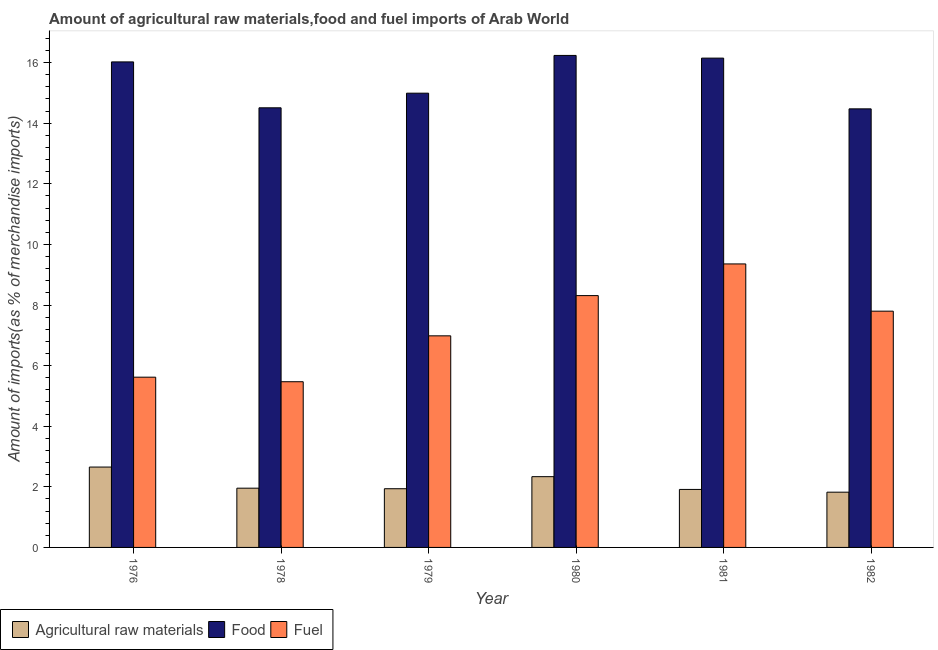Are the number of bars per tick equal to the number of legend labels?
Provide a short and direct response. Yes. Are the number of bars on each tick of the X-axis equal?
Make the answer very short. Yes. How many bars are there on the 6th tick from the left?
Offer a very short reply. 3. What is the percentage of fuel imports in 1976?
Give a very brief answer. 5.62. Across all years, what is the maximum percentage of food imports?
Make the answer very short. 16.24. Across all years, what is the minimum percentage of raw materials imports?
Provide a short and direct response. 1.82. In which year was the percentage of fuel imports maximum?
Offer a very short reply. 1981. In which year was the percentage of fuel imports minimum?
Your answer should be very brief. 1978. What is the total percentage of fuel imports in the graph?
Your answer should be compact. 43.53. What is the difference between the percentage of raw materials imports in 1981 and that in 1982?
Keep it short and to the point. 0.09. What is the difference between the percentage of raw materials imports in 1981 and the percentage of fuel imports in 1979?
Keep it short and to the point. -0.02. What is the average percentage of food imports per year?
Give a very brief answer. 15.4. What is the ratio of the percentage of fuel imports in 1981 to that in 1982?
Make the answer very short. 1.2. Is the percentage of fuel imports in 1980 less than that in 1982?
Provide a short and direct response. No. Is the difference between the percentage of raw materials imports in 1978 and 1981 greater than the difference between the percentage of food imports in 1978 and 1981?
Your answer should be compact. No. What is the difference between the highest and the second highest percentage of food imports?
Offer a terse response. 0.09. What is the difference between the highest and the lowest percentage of food imports?
Give a very brief answer. 1.76. In how many years, is the percentage of fuel imports greater than the average percentage of fuel imports taken over all years?
Provide a short and direct response. 3. Is the sum of the percentage of fuel imports in 1976 and 1980 greater than the maximum percentage of food imports across all years?
Offer a terse response. Yes. What does the 3rd bar from the left in 1979 represents?
Provide a short and direct response. Fuel. What does the 1st bar from the right in 1980 represents?
Your response must be concise. Fuel. Is it the case that in every year, the sum of the percentage of raw materials imports and percentage of food imports is greater than the percentage of fuel imports?
Offer a terse response. Yes. How many bars are there?
Offer a very short reply. 18. Are the values on the major ticks of Y-axis written in scientific E-notation?
Your response must be concise. No. Where does the legend appear in the graph?
Keep it short and to the point. Bottom left. How many legend labels are there?
Offer a terse response. 3. How are the legend labels stacked?
Your answer should be very brief. Horizontal. What is the title of the graph?
Offer a terse response. Amount of agricultural raw materials,food and fuel imports of Arab World. What is the label or title of the X-axis?
Offer a very short reply. Year. What is the label or title of the Y-axis?
Give a very brief answer. Amount of imports(as % of merchandise imports). What is the Amount of imports(as % of merchandise imports) in Agricultural raw materials in 1976?
Your response must be concise. 2.65. What is the Amount of imports(as % of merchandise imports) of Food in 1976?
Give a very brief answer. 16.02. What is the Amount of imports(as % of merchandise imports) in Fuel in 1976?
Your response must be concise. 5.62. What is the Amount of imports(as % of merchandise imports) in Agricultural raw materials in 1978?
Offer a terse response. 1.96. What is the Amount of imports(as % of merchandise imports) in Food in 1978?
Give a very brief answer. 14.51. What is the Amount of imports(as % of merchandise imports) in Fuel in 1978?
Ensure brevity in your answer.  5.47. What is the Amount of imports(as % of merchandise imports) of Agricultural raw materials in 1979?
Provide a succinct answer. 1.94. What is the Amount of imports(as % of merchandise imports) of Food in 1979?
Offer a terse response. 14.99. What is the Amount of imports(as % of merchandise imports) of Fuel in 1979?
Make the answer very short. 6.98. What is the Amount of imports(as % of merchandise imports) of Agricultural raw materials in 1980?
Keep it short and to the point. 2.34. What is the Amount of imports(as % of merchandise imports) of Food in 1980?
Your response must be concise. 16.24. What is the Amount of imports(as % of merchandise imports) of Fuel in 1980?
Offer a terse response. 8.31. What is the Amount of imports(as % of merchandise imports) of Agricultural raw materials in 1981?
Offer a terse response. 1.91. What is the Amount of imports(as % of merchandise imports) of Food in 1981?
Offer a very short reply. 16.15. What is the Amount of imports(as % of merchandise imports) in Fuel in 1981?
Your answer should be very brief. 9.36. What is the Amount of imports(as % of merchandise imports) of Agricultural raw materials in 1982?
Your answer should be very brief. 1.82. What is the Amount of imports(as % of merchandise imports) of Food in 1982?
Provide a short and direct response. 14.47. What is the Amount of imports(as % of merchandise imports) of Fuel in 1982?
Provide a succinct answer. 7.8. Across all years, what is the maximum Amount of imports(as % of merchandise imports) in Agricultural raw materials?
Provide a short and direct response. 2.65. Across all years, what is the maximum Amount of imports(as % of merchandise imports) in Food?
Provide a short and direct response. 16.24. Across all years, what is the maximum Amount of imports(as % of merchandise imports) of Fuel?
Your answer should be very brief. 9.36. Across all years, what is the minimum Amount of imports(as % of merchandise imports) in Agricultural raw materials?
Your response must be concise. 1.82. Across all years, what is the minimum Amount of imports(as % of merchandise imports) of Food?
Make the answer very short. 14.47. Across all years, what is the minimum Amount of imports(as % of merchandise imports) in Fuel?
Your answer should be very brief. 5.47. What is the total Amount of imports(as % of merchandise imports) of Agricultural raw materials in the graph?
Make the answer very short. 12.62. What is the total Amount of imports(as % of merchandise imports) of Food in the graph?
Your response must be concise. 92.38. What is the total Amount of imports(as % of merchandise imports) of Fuel in the graph?
Your response must be concise. 43.53. What is the difference between the Amount of imports(as % of merchandise imports) of Agricultural raw materials in 1976 and that in 1978?
Provide a short and direct response. 0.7. What is the difference between the Amount of imports(as % of merchandise imports) in Food in 1976 and that in 1978?
Your response must be concise. 1.51. What is the difference between the Amount of imports(as % of merchandise imports) of Agricultural raw materials in 1976 and that in 1979?
Offer a very short reply. 0.71. What is the difference between the Amount of imports(as % of merchandise imports) of Food in 1976 and that in 1979?
Give a very brief answer. 1.03. What is the difference between the Amount of imports(as % of merchandise imports) in Fuel in 1976 and that in 1979?
Give a very brief answer. -1.36. What is the difference between the Amount of imports(as % of merchandise imports) of Agricultural raw materials in 1976 and that in 1980?
Your response must be concise. 0.32. What is the difference between the Amount of imports(as % of merchandise imports) of Food in 1976 and that in 1980?
Make the answer very short. -0.21. What is the difference between the Amount of imports(as % of merchandise imports) of Fuel in 1976 and that in 1980?
Your response must be concise. -2.69. What is the difference between the Amount of imports(as % of merchandise imports) of Agricultural raw materials in 1976 and that in 1981?
Ensure brevity in your answer.  0.74. What is the difference between the Amount of imports(as % of merchandise imports) in Food in 1976 and that in 1981?
Make the answer very short. -0.12. What is the difference between the Amount of imports(as % of merchandise imports) in Fuel in 1976 and that in 1981?
Your answer should be compact. -3.74. What is the difference between the Amount of imports(as % of merchandise imports) in Agricultural raw materials in 1976 and that in 1982?
Make the answer very short. 0.83. What is the difference between the Amount of imports(as % of merchandise imports) in Food in 1976 and that in 1982?
Provide a succinct answer. 1.55. What is the difference between the Amount of imports(as % of merchandise imports) of Fuel in 1976 and that in 1982?
Provide a short and direct response. -2.18. What is the difference between the Amount of imports(as % of merchandise imports) of Agricultural raw materials in 1978 and that in 1979?
Give a very brief answer. 0.02. What is the difference between the Amount of imports(as % of merchandise imports) in Food in 1978 and that in 1979?
Your response must be concise. -0.48. What is the difference between the Amount of imports(as % of merchandise imports) of Fuel in 1978 and that in 1979?
Ensure brevity in your answer.  -1.51. What is the difference between the Amount of imports(as % of merchandise imports) in Agricultural raw materials in 1978 and that in 1980?
Give a very brief answer. -0.38. What is the difference between the Amount of imports(as % of merchandise imports) of Food in 1978 and that in 1980?
Offer a terse response. -1.73. What is the difference between the Amount of imports(as % of merchandise imports) in Fuel in 1978 and that in 1980?
Ensure brevity in your answer.  -2.84. What is the difference between the Amount of imports(as % of merchandise imports) of Agricultural raw materials in 1978 and that in 1981?
Keep it short and to the point. 0.04. What is the difference between the Amount of imports(as % of merchandise imports) in Food in 1978 and that in 1981?
Give a very brief answer. -1.64. What is the difference between the Amount of imports(as % of merchandise imports) in Fuel in 1978 and that in 1981?
Make the answer very short. -3.89. What is the difference between the Amount of imports(as % of merchandise imports) in Agricultural raw materials in 1978 and that in 1982?
Offer a very short reply. 0.13. What is the difference between the Amount of imports(as % of merchandise imports) of Food in 1978 and that in 1982?
Provide a succinct answer. 0.03. What is the difference between the Amount of imports(as % of merchandise imports) in Fuel in 1978 and that in 1982?
Your answer should be compact. -2.33. What is the difference between the Amount of imports(as % of merchandise imports) of Agricultural raw materials in 1979 and that in 1980?
Provide a short and direct response. -0.4. What is the difference between the Amount of imports(as % of merchandise imports) of Food in 1979 and that in 1980?
Make the answer very short. -1.25. What is the difference between the Amount of imports(as % of merchandise imports) in Fuel in 1979 and that in 1980?
Give a very brief answer. -1.33. What is the difference between the Amount of imports(as % of merchandise imports) in Agricultural raw materials in 1979 and that in 1981?
Make the answer very short. 0.02. What is the difference between the Amount of imports(as % of merchandise imports) of Food in 1979 and that in 1981?
Give a very brief answer. -1.16. What is the difference between the Amount of imports(as % of merchandise imports) in Fuel in 1979 and that in 1981?
Provide a short and direct response. -2.37. What is the difference between the Amount of imports(as % of merchandise imports) in Agricultural raw materials in 1979 and that in 1982?
Offer a terse response. 0.11. What is the difference between the Amount of imports(as % of merchandise imports) in Food in 1979 and that in 1982?
Provide a succinct answer. 0.52. What is the difference between the Amount of imports(as % of merchandise imports) in Fuel in 1979 and that in 1982?
Give a very brief answer. -0.81. What is the difference between the Amount of imports(as % of merchandise imports) of Agricultural raw materials in 1980 and that in 1981?
Keep it short and to the point. 0.42. What is the difference between the Amount of imports(as % of merchandise imports) in Food in 1980 and that in 1981?
Make the answer very short. 0.09. What is the difference between the Amount of imports(as % of merchandise imports) of Fuel in 1980 and that in 1981?
Keep it short and to the point. -1.05. What is the difference between the Amount of imports(as % of merchandise imports) in Agricultural raw materials in 1980 and that in 1982?
Your answer should be very brief. 0.51. What is the difference between the Amount of imports(as % of merchandise imports) in Food in 1980 and that in 1982?
Your answer should be very brief. 1.76. What is the difference between the Amount of imports(as % of merchandise imports) of Fuel in 1980 and that in 1982?
Ensure brevity in your answer.  0.51. What is the difference between the Amount of imports(as % of merchandise imports) in Agricultural raw materials in 1981 and that in 1982?
Offer a very short reply. 0.09. What is the difference between the Amount of imports(as % of merchandise imports) in Food in 1981 and that in 1982?
Your answer should be very brief. 1.67. What is the difference between the Amount of imports(as % of merchandise imports) in Fuel in 1981 and that in 1982?
Give a very brief answer. 1.56. What is the difference between the Amount of imports(as % of merchandise imports) of Agricultural raw materials in 1976 and the Amount of imports(as % of merchandise imports) of Food in 1978?
Your answer should be compact. -11.86. What is the difference between the Amount of imports(as % of merchandise imports) of Agricultural raw materials in 1976 and the Amount of imports(as % of merchandise imports) of Fuel in 1978?
Give a very brief answer. -2.82. What is the difference between the Amount of imports(as % of merchandise imports) in Food in 1976 and the Amount of imports(as % of merchandise imports) in Fuel in 1978?
Give a very brief answer. 10.55. What is the difference between the Amount of imports(as % of merchandise imports) in Agricultural raw materials in 1976 and the Amount of imports(as % of merchandise imports) in Food in 1979?
Your answer should be very brief. -12.34. What is the difference between the Amount of imports(as % of merchandise imports) of Agricultural raw materials in 1976 and the Amount of imports(as % of merchandise imports) of Fuel in 1979?
Your response must be concise. -4.33. What is the difference between the Amount of imports(as % of merchandise imports) of Food in 1976 and the Amount of imports(as % of merchandise imports) of Fuel in 1979?
Keep it short and to the point. 9.04. What is the difference between the Amount of imports(as % of merchandise imports) of Agricultural raw materials in 1976 and the Amount of imports(as % of merchandise imports) of Food in 1980?
Ensure brevity in your answer.  -13.58. What is the difference between the Amount of imports(as % of merchandise imports) of Agricultural raw materials in 1976 and the Amount of imports(as % of merchandise imports) of Fuel in 1980?
Make the answer very short. -5.66. What is the difference between the Amount of imports(as % of merchandise imports) of Food in 1976 and the Amount of imports(as % of merchandise imports) of Fuel in 1980?
Ensure brevity in your answer.  7.71. What is the difference between the Amount of imports(as % of merchandise imports) in Agricultural raw materials in 1976 and the Amount of imports(as % of merchandise imports) in Food in 1981?
Ensure brevity in your answer.  -13.5. What is the difference between the Amount of imports(as % of merchandise imports) in Agricultural raw materials in 1976 and the Amount of imports(as % of merchandise imports) in Fuel in 1981?
Your response must be concise. -6.7. What is the difference between the Amount of imports(as % of merchandise imports) of Food in 1976 and the Amount of imports(as % of merchandise imports) of Fuel in 1981?
Offer a very short reply. 6.67. What is the difference between the Amount of imports(as % of merchandise imports) of Agricultural raw materials in 1976 and the Amount of imports(as % of merchandise imports) of Food in 1982?
Offer a terse response. -11.82. What is the difference between the Amount of imports(as % of merchandise imports) of Agricultural raw materials in 1976 and the Amount of imports(as % of merchandise imports) of Fuel in 1982?
Your answer should be very brief. -5.14. What is the difference between the Amount of imports(as % of merchandise imports) of Food in 1976 and the Amount of imports(as % of merchandise imports) of Fuel in 1982?
Offer a terse response. 8.23. What is the difference between the Amount of imports(as % of merchandise imports) in Agricultural raw materials in 1978 and the Amount of imports(as % of merchandise imports) in Food in 1979?
Give a very brief answer. -13.04. What is the difference between the Amount of imports(as % of merchandise imports) of Agricultural raw materials in 1978 and the Amount of imports(as % of merchandise imports) of Fuel in 1979?
Provide a succinct answer. -5.03. What is the difference between the Amount of imports(as % of merchandise imports) of Food in 1978 and the Amount of imports(as % of merchandise imports) of Fuel in 1979?
Offer a terse response. 7.53. What is the difference between the Amount of imports(as % of merchandise imports) of Agricultural raw materials in 1978 and the Amount of imports(as % of merchandise imports) of Food in 1980?
Give a very brief answer. -14.28. What is the difference between the Amount of imports(as % of merchandise imports) of Agricultural raw materials in 1978 and the Amount of imports(as % of merchandise imports) of Fuel in 1980?
Offer a very short reply. -6.36. What is the difference between the Amount of imports(as % of merchandise imports) in Food in 1978 and the Amount of imports(as % of merchandise imports) in Fuel in 1980?
Your answer should be compact. 6.2. What is the difference between the Amount of imports(as % of merchandise imports) of Agricultural raw materials in 1978 and the Amount of imports(as % of merchandise imports) of Food in 1981?
Keep it short and to the point. -14.19. What is the difference between the Amount of imports(as % of merchandise imports) in Agricultural raw materials in 1978 and the Amount of imports(as % of merchandise imports) in Fuel in 1981?
Ensure brevity in your answer.  -7.4. What is the difference between the Amount of imports(as % of merchandise imports) of Food in 1978 and the Amount of imports(as % of merchandise imports) of Fuel in 1981?
Provide a short and direct response. 5.15. What is the difference between the Amount of imports(as % of merchandise imports) in Agricultural raw materials in 1978 and the Amount of imports(as % of merchandise imports) in Food in 1982?
Make the answer very short. -12.52. What is the difference between the Amount of imports(as % of merchandise imports) in Agricultural raw materials in 1978 and the Amount of imports(as % of merchandise imports) in Fuel in 1982?
Offer a terse response. -5.84. What is the difference between the Amount of imports(as % of merchandise imports) in Food in 1978 and the Amount of imports(as % of merchandise imports) in Fuel in 1982?
Offer a terse response. 6.71. What is the difference between the Amount of imports(as % of merchandise imports) in Agricultural raw materials in 1979 and the Amount of imports(as % of merchandise imports) in Food in 1980?
Your answer should be compact. -14.3. What is the difference between the Amount of imports(as % of merchandise imports) in Agricultural raw materials in 1979 and the Amount of imports(as % of merchandise imports) in Fuel in 1980?
Provide a succinct answer. -6.37. What is the difference between the Amount of imports(as % of merchandise imports) of Food in 1979 and the Amount of imports(as % of merchandise imports) of Fuel in 1980?
Offer a very short reply. 6.68. What is the difference between the Amount of imports(as % of merchandise imports) of Agricultural raw materials in 1979 and the Amount of imports(as % of merchandise imports) of Food in 1981?
Offer a very short reply. -14.21. What is the difference between the Amount of imports(as % of merchandise imports) of Agricultural raw materials in 1979 and the Amount of imports(as % of merchandise imports) of Fuel in 1981?
Your answer should be compact. -7.42. What is the difference between the Amount of imports(as % of merchandise imports) in Food in 1979 and the Amount of imports(as % of merchandise imports) in Fuel in 1981?
Your answer should be very brief. 5.63. What is the difference between the Amount of imports(as % of merchandise imports) of Agricultural raw materials in 1979 and the Amount of imports(as % of merchandise imports) of Food in 1982?
Your answer should be compact. -12.54. What is the difference between the Amount of imports(as % of merchandise imports) in Agricultural raw materials in 1979 and the Amount of imports(as % of merchandise imports) in Fuel in 1982?
Your answer should be compact. -5.86. What is the difference between the Amount of imports(as % of merchandise imports) in Food in 1979 and the Amount of imports(as % of merchandise imports) in Fuel in 1982?
Provide a short and direct response. 7.19. What is the difference between the Amount of imports(as % of merchandise imports) in Agricultural raw materials in 1980 and the Amount of imports(as % of merchandise imports) in Food in 1981?
Keep it short and to the point. -13.81. What is the difference between the Amount of imports(as % of merchandise imports) in Agricultural raw materials in 1980 and the Amount of imports(as % of merchandise imports) in Fuel in 1981?
Give a very brief answer. -7.02. What is the difference between the Amount of imports(as % of merchandise imports) of Food in 1980 and the Amount of imports(as % of merchandise imports) of Fuel in 1981?
Ensure brevity in your answer.  6.88. What is the difference between the Amount of imports(as % of merchandise imports) in Agricultural raw materials in 1980 and the Amount of imports(as % of merchandise imports) in Food in 1982?
Offer a terse response. -12.14. What is the difference between the Amount of imports(as % of merchandise imports) in Agricultural raw materials in 1980 and the Amount of imports(as % of merchandise imports) in Fuel in 1982?
Provide a short and direct response. -5.46. What is the difference between the Amount of imports(as % of merchandise imports) in Food in 1980 and the Amount of imports(as % of merchandise imports) in Fuel in 1982?
Make the answer very short. 8.44. What is the difference between the Amount of imports(as % of merchandise imports) of Agricultural raw materials in 1981 and the Amount of imports(as % of merchandise imports) of Food in 1982?
Provide a succinct answer. -12.56. What is the difference between the Amount of imports(as % of merchandise imports) of Agricultural raw materials in 1981 and the Amount of imports(as % of merchandise imports) of Fuel in 1982?
Provide a succinct answer. -5.88. What is the difference between the Amount of imports(as % of merchandise imports) in Food in 1981 and the Amount of imports(as % of merchandise imports) in Fuel in 1982?
Your answer should be very brief. 8.35. What is the average Amount of imports(as % of merchandise imports) in Agricultural raw materials per year?
Provide a short and direct response. 2.1. What is the average Amount of imports(as % of merchandise imports) in Food per year?
Keep it short and to the point. 15.4. What is the average Amount of imports(as % of merchandise imports) in Fuel per year?
Your answer should be compact. 7.26. In the year 1976, what is the difference between the Amount of imports(as % of merchandise imports) of Agricultural raw materials and Amount of imports(as % of merchandise imports) of Food?
Your answer should be very brief. -13.37. In the year 1976, what is the difference between the Amount of imports(as % of merchandise imports) of Agricultural raw materials and Amount of imports(as % of merchandise imports) of Fuel?
Provide a succinct answer. -2.97. In the year 1976, what is the difference between the Amount of imports(as % of merchandise imports) of Food and Amount of imports(as % of merchandise imports) of Fuel?
Keep it short and to the point. 10.4. In the year 1978, what is the difference between the Amount of imports(as % of merchandise imports) in Agricultural raw materials and Amount of imports(as % of merchandise imports) in Food?
Your answer should be compact. -12.55. In the year 1978, what is the difference between the Amount of imports(as % of merchandise imports) of Agricultural raw materials and Amount of imports(as % of merchandise imports) of Fuel?
Make the answer very short. -3.51. In the year 1978, what is the difference between the Amount of imports(as % of merchandise imports) of Food and Amount of imports(as % of merchandise imports) of Fuel?
Your response must be concise. 9.04. In the year 1979, what is the difference between the Amount of imports(as % of merchandise imports) of Agricultural raw materials and Amount of imports(as % of merchandise imports) of Food?
Ensure brevity in your answer.  -13.05. In the year 1979, what is the difference between the Amount of imports(as % of merchandise imports) in Agricultural raw materials and Amount of imports(as % of merchandise imports) in Fuel?
Your answer should be compact. -5.05. In the year 1979, what is the difference between the Amount of imports(as % of merchandise imports) in Food and Amount of imports(as % of merchandise imports) in Fuel?
Provide a short and direct response. 8.01. In the year 1980, what is the difference between the Amount of imports(as % of merchandise imports) of Agricultural raw materials and Amount of imports(as % of merchandise imports) of Food?
Your response must be concise. -13.9. In the year 1980, what is the difference between the Amount of imports(as % of merchandise imports) of Agricultural raw materials and Amount of imports(as % of merchandise imports) of Fuel?
Your response must be concise. -5.97. In the year 1980, what is the difference between the Amount of imports(as % of merchandise imports) of Food and Amount of imports(as % of merchandise imports) of Fuel?
Ensure brevity in your answer.  7.93. In the year 1981, what is the difference between the Amount of imports(as % of merchandise imports) in Agricultural raw materials and Amount of imports(as % of merchandise imports) in Food?
Ensure brevity in your answer.  -14.23. In the year 1981, what is the difference between the Amount of imports(as % of merchandise imports) of Agricultural raw materials and Amount of imports(as % of merchandise imports) of Fuel?
Provide a short and direct response. -7.44. In the year 1981, what is the difference between the Amount of imports(as % of merchandise imports) in Food and Amount of imports(as % of merchandise imports) in Fuel?
Your response must be concise. 6.79. In the year 1982, what is the difference between the Amount of imports(as % of merchandise imports) in Agricultural raw materials and Amount of imports(as % of merchandise imports) in Food?
Offer a terse response. -12.65. In the year 1982, what is the difference between the Amount of imports(as % of merchandise imports) of Agricultural raw materials and Amount of imports(as % of merchandise imports) of Fuel?
Provide a short and direct response. -5.97. In the year 1982, what is the difference between the Amount of imports(as % of merchandise imports) in Food and Amount of imports(as % of merchandise imports) in Fuel?
Offer a terse response. 6.68. What is the ratio of the Amount of imports(as % of merchandise imports) in Agricultural raw materials in 1976 to that in 1978?
Keep it short and to the point. 1.36. What is the ratio of the Amount of imports(as % of merchandise imports) in Food in 1976 to that in 1978?
Give a very brief answer. 1.1. What is the ratio of the Amount of imports(as % of merchandise imports) of Fuel in 1976 to that in 1978?
Ensure brevity in your answer.  1.03. What is the ratio of the Amount of imports(as % of merchandise imports) in Agricultural raw materials in 1976 to that in 1979?
Offer a terse response. 1.37. What is the ratio of the Amount of imports(as % of merchandise imports) in Food in 1976 to that in 1979?
Keep it short and to the point. 1.07. What is the ratio of the Amount of imports(as % of merchandise imports) of Fuel in 1976 to that in 1979?
Offer a very short reply. 0.8. What is the ratio of the Amount of imports(as % of merchandise imports) of Agricultural raw materials in 1976 to that in 1980?
Your response must be concise. 1.14. What is the ratio of the Amount of imports(as % of merchandise imports) in Fuel in 1976 to that in 1980?
Your response must be concise. 0.68. What is the ratio of the Amount of imports(as % of merchandise imports) of Agricultural raw materials in 1976 to that in 1981?
Make the answer very short. 1.39. What is the ratio of the Amount of imports(as % of merchandise imports) in Food in 1976 to that in 1981?
Provide a short and direct response. 0.99. What is the ratio of the Amount of imports(as % of merchandise imports) of Fuel in 1976 to that in 1981?
Ensure brevity in your answer.  0.6. What is the ratio of the Amount of imports(as % of merchandise imports) in Agricultural raw materials in 1976 to that in 1982?
Give a very brief answer. 1.45. What is the ratio of the Amount of imports(as % of merchandise imports) in Food in 1976 to that in 1982?
Your answer should be compact. 1.11. What is the ratio of the Amount of imports(as % of merchandise imports) of Fuel in 1976 to that in 1982?
Provide a succinct answer. 0.72. What is the ratio of the Amount of imports(as % of merchandise imports) in Agricultural raw materials in 1978 to that in 1979?
Keep it short and to the point. 1.01. What is the ratio of the Amount of imports(as % of merchandise imports) in Food in 1978 to that in 1979?
Your answer should be compact. 0.97. What is the ratio of the Amount of imports(as % of merchandise imports) of Fuel in 1978 to that in 1979?
Provide a short and direct response. 0.78. What is the ratio of the Amount of imports(as % of merchandise imports) of Agricultural raw materials in 1978 to that in 1980?
Give a very brief answer. 0.84. What is the ratio of the Amount of imports(as % of merchandise imports) of Food in 1978 to that in 1980?
Offer a very short reply. 0.89. What is the ratio of the Amount of imports(as % of merchandise imports) of Fuel in 1978 to that in 1980?
Make the answer very short. 0.66. What is the ratio of the Amount of imports(as % of merchandise imports) in Agricultural raw materials in 1978 to that in 1981?
Your response must be concise. 1.02. What is the ratio of the Amount of imports(as % of merchandise imports) of Food in 1978 to that in 1981?
Give a very brief answer. 0.9. What is the ratio of the Amount of imports(as % of merchandise imports) in Fuel in 1978 to that in 1981?
Your answer should be very brief. 0.58. What is the ratio of the Amount of imports(as % of merchandise imports) in Agricultural raw materials in 1978 to that in 1982?
Make the answer very short. 1.07. What is the ratio of the Amount of imports(as % of merchandise imports) in Food in 1978 to that in 1982?
Your answer should be compact. 1. What is the ratio of the Amount of imports(as % of merchandise imports) of Fuel in 1978 to that in 1982?
Make the answer very short. 0.7. What is the ratio of the Amount of imports(as % of merchandise imports) in Agricultural raw materials in 1979 to that in 1980?
Keep it short and to the point. 0.83. What is the ratio of the Amount of imports(as % of merchandise imports) of Food in 1979 to that in 1980?
Provide a short and direct response. 0.92. What is the ratio of the Amount of imports(as % of merchandise imports) of Fuel in 1979 to that in 1980?
Provide a succinct answer. 0.84. What is the ratio of the Amount of imports(as % of merchandise imports) of Agricultural raw materials in 1979 to that in 1981?
Provide a succinct answer. 1.01. What is the ratio of the Amount of imports(as % of merchandise imports) of Food in 1979 to that in 1981?
Offer a very short reply. 0.93. What is the ratio of the Amount of imports(as % of merchandise imports) of Fuel in 1979 to that in 1981?
Offer a terse response. 0.75. What is the ratio of the Amount of imports(as % of merchandise imports) in Agricultural raw materials in 1979 to that in 1982?
Give a very brief answer. 1.06. What is the ratio of the Amount of imports(as % of merchandise imports) in Food in 1979 to that in 1982?
Your response must be concise. 1.04. What is the ratio of the Amount of imports(as % of merchandise imports) of Fuel in 1979 to that in 1982?
Give a very brief answer. 0.9. What is the ratio of the Amount of imports(as % of merchandise imports) of Agricultural raw materials in 1980 to that in 1981?
Offer a terse response. 1.22. What is the ratio of the Amount of imports(as % of merchandise imports) in Food in 1980 to that in 1981?
Offer a very short reply. 1.01. What is the ratio of the Amount of imports(as % of merchandise imports) of Fuel in 1980 to that in 1981?
Offer a very short reply. 0.89. What is the ratio of the Amount of imports(as % of merchandise imports) of Agricultural raw materials in 1980 to that in 1982?
Ensure brevity in your answer.  1.28. What is the ratio of the Amount of imports(as % of merchandise imports) in Food in 1980 to that in 1982?
Offer a very short reply. 1.12. What is the ratio of the Amount of imports(as % of merchandise imports) in Fuel in 1980 to that in 1982?
Offer a very short reply. 1.07. What is the ratio of the Amount of imports(as % of merchandise imports) of Agricultural raw materials in 1981 to that in 1982?
Your answer should be compact. 1.05. What is the ratio of the Amount of imports(as % of merchandise imports) in Food in 1981 to that in 1982?
Offer a very short reply. 1.12. What is the ratio of the Amount of imports(as % of merchandise imports) in Fuel in 1981 to that in 1982?
Provide a short and direct response. 1.2. What is the difference between the highest and the second highest Amount of imports(as % of merchandise imports) in Agricultural raw materials?
Ensure brevity in your answer.  0.32. What is the difference between the highest and the second highest Amount of imports(as % of merchandise imports) in Food?
Provide a short and direct response. 0.09. What is the difference between the highest and the second highest Amount of imports(as % of merchandise imports) in Fuel?
Give a very brief answer. 1.05. What is the difference between the highest and the lowest Amount of imports(as % of merchandise imports) in Agricultural raw materials?
Give a very brief answer. 0.83. What is the difference between the highest and the lowest Amount of imports(as % of merchandise imports) of Food?
Make the answer very short. 1.76. What is the difference between the highest and the lowest Amount of imports(as % of merchandise imports) of Fuel?
Keep it short and to the point. 3.89. 